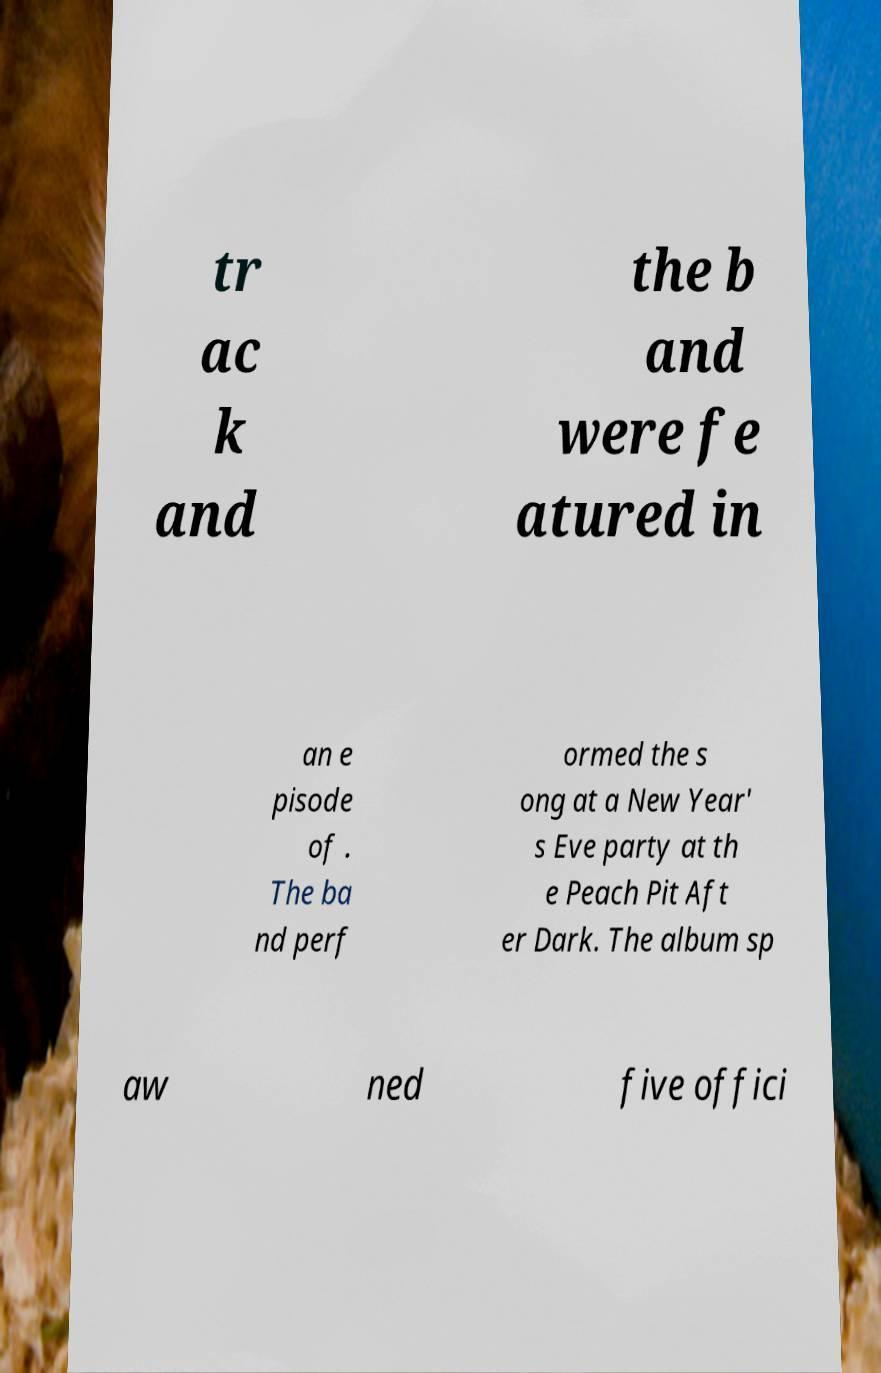Could you extract and type out the text from this image? tr ac k and the b and were fe atured in an e pisode of . The ba nd perf ormed the s ong at a New Year' s Eve party at th e Peach Pit Aft er Dark. The album sp aw ned five offici 